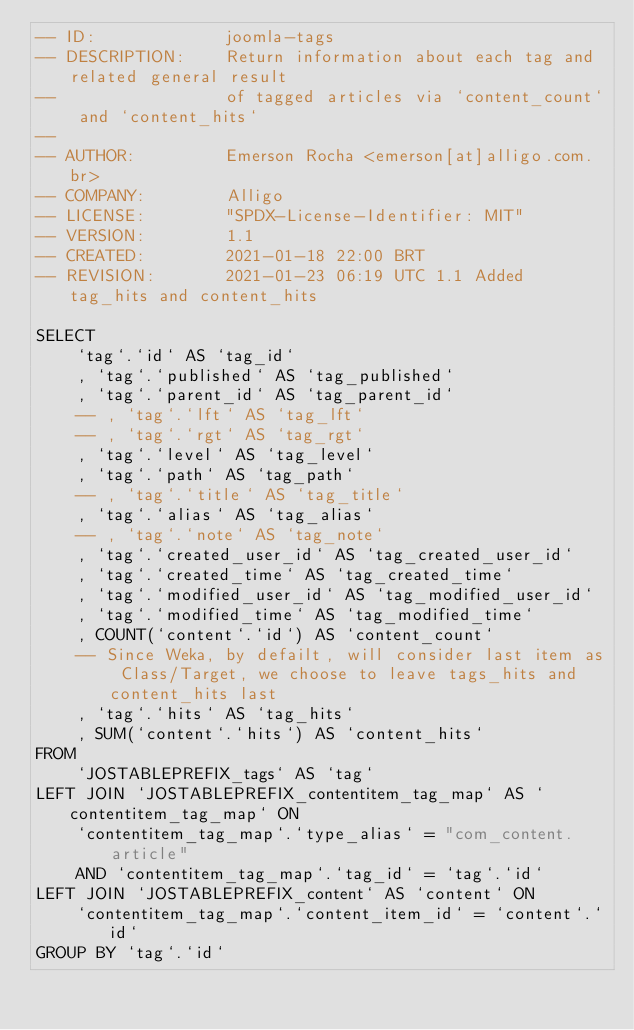<code> <loc_0><loc_0><loc_500><loc_500><_SQL_>-- ID:             joomla-tags
-- DESCRIPTION:    Return information about each tag and related general result
--                 of tagged articles via `content_count` and `content_hits`
--
-- AUTHOR:         Emerson Rocha <emerson[at]alligo.com.br>
-- COMPANY:        Alligo
-- LICENSE:        "SPDX-License-Identifier: MIT"
-- VERSION:        1.1
-- CREATED:        2021-01-18 22:00 BRT
-- REVISION:       2021-01-23 06:19 UTC 1.1 Added tag_hits and content_hits

SELECT
    `tag`.`id` AS `tag_id`
    , `tag`.`published` AS `tag_published`
    , `tag`.`parent_id` AS `tag_parent_id`
    -- , `tag`.`lft` AS `tag_lft`
    -- , `tag`.`rgt` AS `tag_rgt`
    , `tag`.`level` AS `tag_level`
    , `tag`.`path` AS `tag_path`
    -- , `tag`.`title` AS `tag_title`
    , `tag`.`alias` AS `tag_alias`
    -- , `tag`.`note` AS `tag_note`
    , `tag`.`created_user_id` AS `tag_created_user_id`
    , `tag`.`created_time` AS `tag_created_time`
    , `tag`.`modified_user_id` AS `tag_modified_user_id`
    , `tag`.`modified_time` AS `tag_modified_time`
    , COUNT(`content`.`id`) AS `content_count`
    -- Since Weka, by defailt, will consider last item as Class/Target, we choose to leave tags_hits and content_hits last
    , `tag`.`hits` AS `tag_hits`
    , SUM(`content`.`hits`) AS `content_hits`
FROM
    `JOSTABLEPREFIX_tags` AS `tag`
LEFT JOIN `JOSTABLEPREFIX_contentitem_tag_map` AS `contentitem_tag_map` ON
    `contentitem_tag_map`.`type_alias` = "com_content.article" 
    AND `contentitem_tag_map`.`tag_id` = `tag`.`id`
LEFT JOIN `JOSTABLEPREFIX_content` AS `content` ON
    `contentitem_tag_map`.`content_item_id` = `content`.`id`
GROUP BY `tag`.`id`</code> 